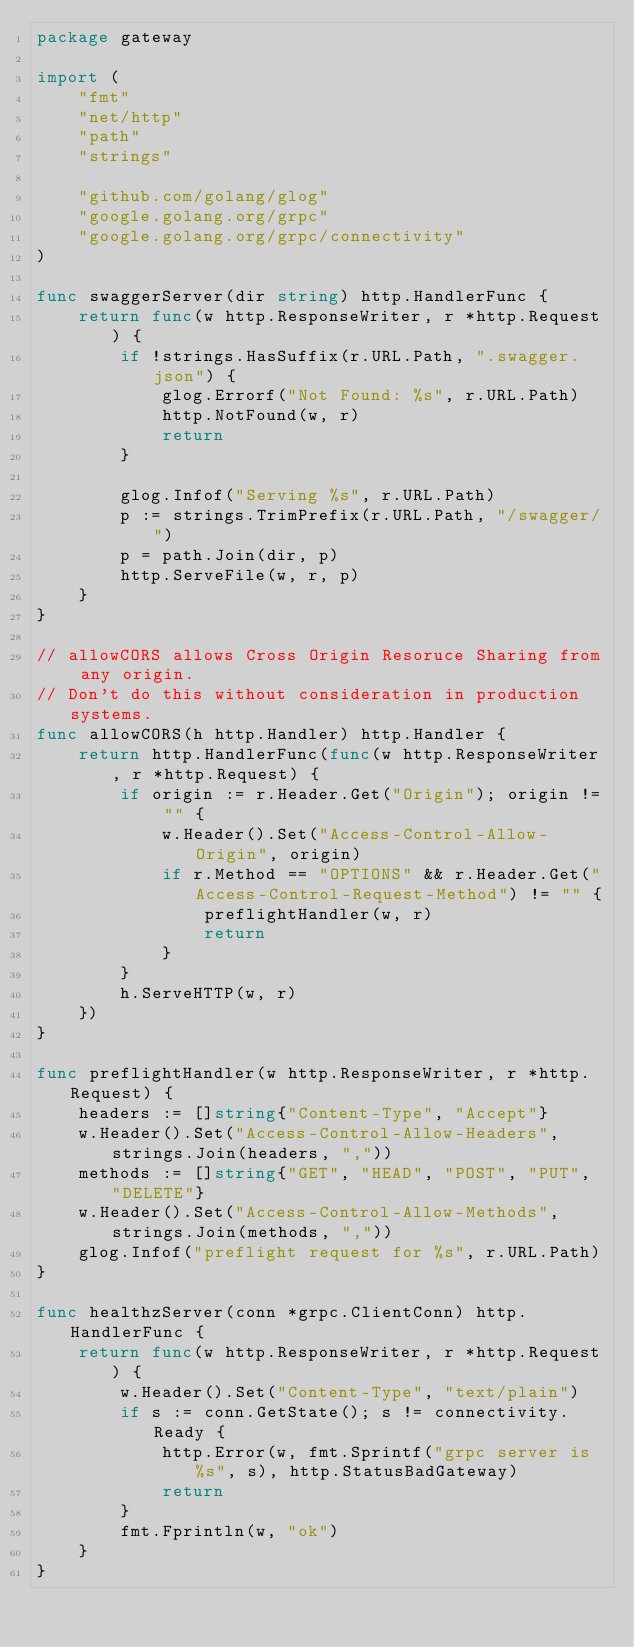<code> <loc_0><loc_0><loc_500><loc_500><_Go_>package gateway

import (
	"fmt"
	"net/http"
	"path"
	"strings"

	"github.com/golang/glog"
	"google.golang.org/grpc"
	"google.golang.org/grpc/connectivity"
)

func swaggerServer(dir string) http.HandlerFunc {
	return func(w http.ResponseWriter, r *http.Request) {
		if !strings.HasSuffix(r.URL.Path, ".swagger.json") {
			glog.Errorf("Not Found: %s", r.URL.Path)
			http.NotFound(w, r)
			return
		}

		glog.Infof("Serving %s", r.URL.Path)
		p := strings.TrimPrefix(r.URL.Path, "/swagger/")
		p = path.Join(dir, p)
		http.ServeFile(w, r, p)
	}
}

// allowCORS allows Cross Origin Resoruce Sharing from any origin.
// Don't do this without consideration in production systems.
func allowCORS(h http.Handler) http.Handler {
	return http.HandlerFunc(func(w http.ResponseWriter, r *http.Request) {
		if origin := r.Header.Get("Origin"); origin != "" {
			w.Header().Set("Access-Control-Allow-Origin", origin)
			if r.Method == "OPTIONS" && r.Header.Get("Access-Control-Request-Method") != "" {
				preflightHandler(w, r)
				return
			}
		}
		h.ServeHTTP(w, r)
	})
}

func preflightHandler(w http.ResponseWriter, r *http.Request) {
	headers := []string{"Content-Type", "Accept"}
	w.Header().Set("Access-Control-Allow-Headers", strings.Join(headers, ","))
	methods := []string{"GET", "HEAD", "POST", "PUT", "DELETE"}
	w.Header().Set("Access-Control-Allow-Methods", strings.Join(methods, ","))
	glog.Infof("preflight request for %s", r.URL.Path)
}

func healthzServer(conn *grpc.ClientConn) http.HandlerFunc {
	return func(w http.ResponseWriter, r *http.Request) {
		w.Header().Set("Content-Type", "text/plain")
		if s := conn.GetState(); s != connectivity.Ready {
			http.Error(w, fmt.Sprintf("grpc server is %s", s), http.StatusBadGateway)
			return
		}
		fmt.Fprintln(w, "ok")
	}
}
</code> 